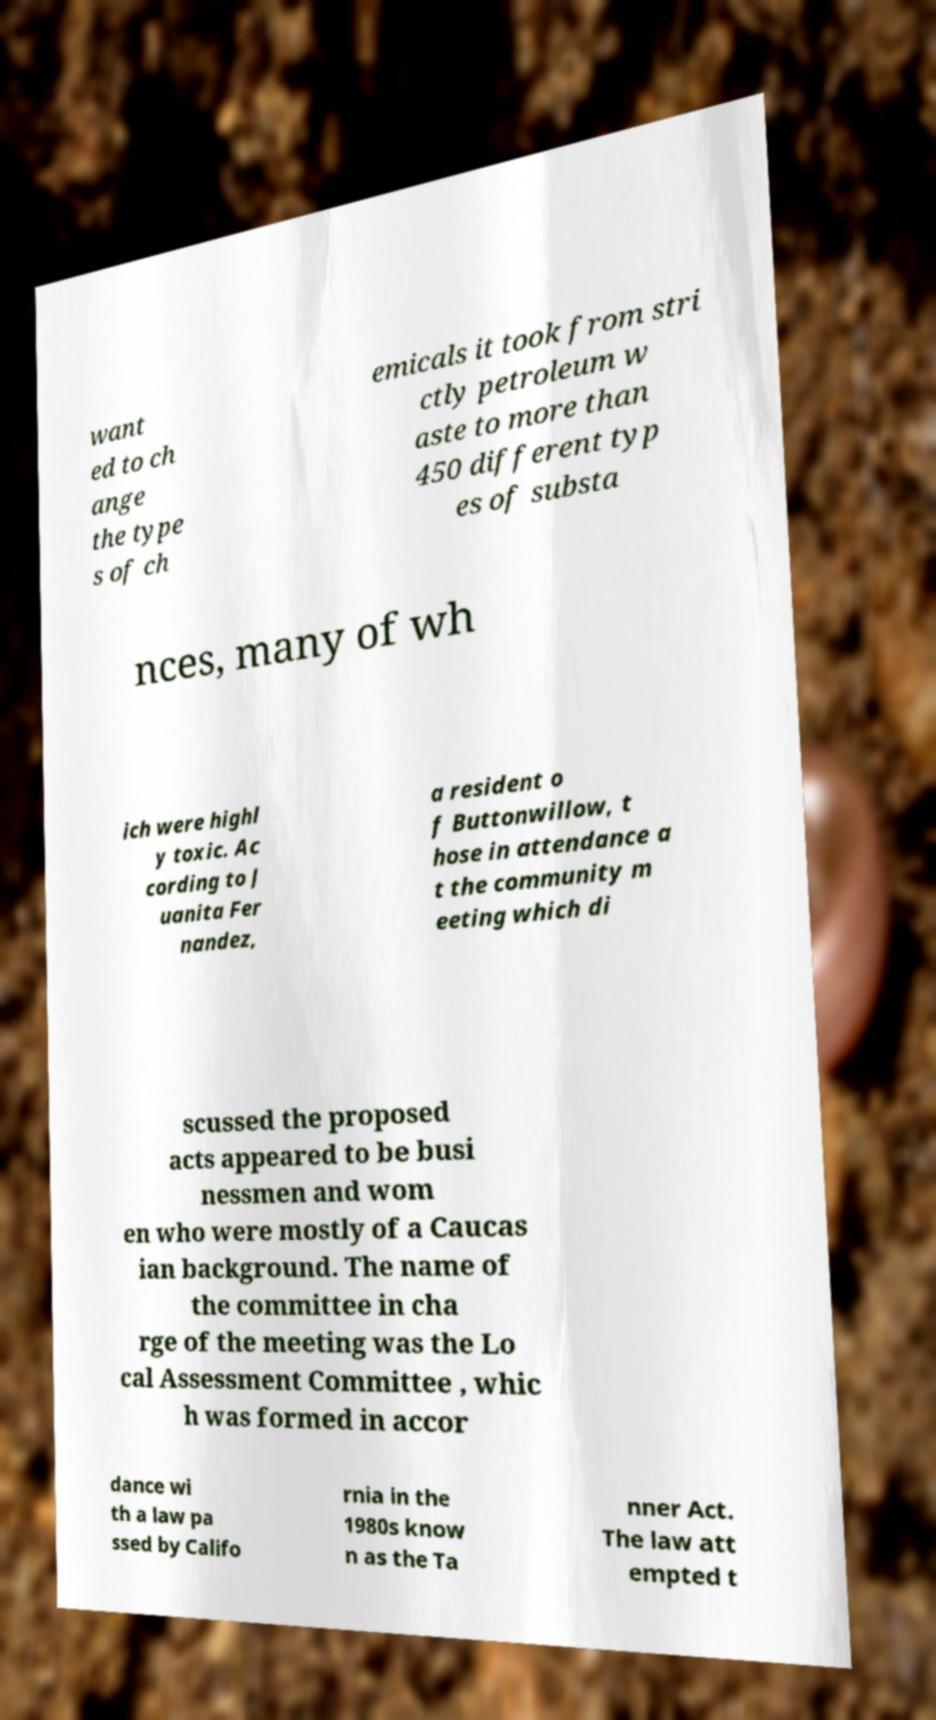Please read and relay the text visible in this image. What does it say? want ed to ch ange the type s of ch emicals it took from stri ctly petroleum w aste to more than 450 different typ es of substa nces, many of wh ich were highl y toxic. Ac cording to J uanita Fer nandez, a resident o f Buttonwillow, t hose in attendance a t the community m eeting which di scussed the proposed acts appeared to be busi nessmen and wom en who were mostly of a Caucas ian background. The name of the committee in cha rge of the meeting was the Lo cal Assessment Committee , whic h was formed in accor dance wi th a law pa ssed by Califo rnia in the 1980s know n as the Ta nner Act. The law att empted t 